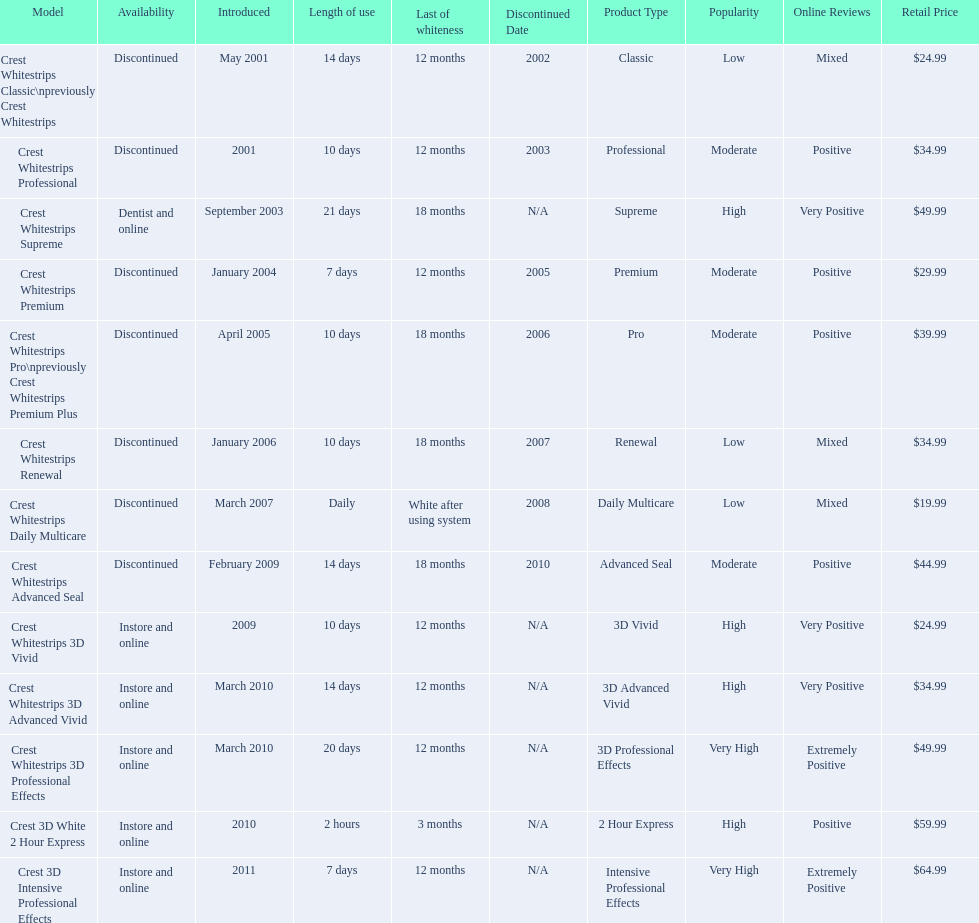What were the models of crest whitestrips? Crest Whitestrips Classic\npreviously Crest Whitestrips, Crest Whitestrips Professional, Crest Whitestrips Supreme, Crest Whitestrips Premium, Crest Whitestrips Pro\npreviously Crest Whitestrips Premium Plus, Crest Whitestrips Renewal, Crest Whitestrips Daily Multicare, Crest Whitestrips Advanced Seal, Crest Whitestrips 3D Vivid, Crest Whitestrips 3D Advanced Vivid, Crest Whitestrips 3D Professional Effects, Crest 3D White 2 Hour Express, Crest 3D Intensive Professional Effects. Can you parse all the data within this table? {'header': ['Model', 'Availability', 'Introduced', 'Length of use', 'Last of whiteness', 'Discontinued Date', 'Product Type', 'Popularity', 'Online Reviews', 'Retail Price'], 'rows': [['Crest Whitestrips Classic\\npreviously Crest Whitestrips', 'Discontinued', 'May 2001', '14 days', '12 months', '2002', 'Classic', 'Low', 'Mixed', '$24.99'], ['Crest Whitestrips Professional', 'Discontinued', '2001', '10 days', '12 months', '2003', 'Professional', 'Moderate', 'Positive', '$34.99'], ['Crest Whitestrips Supreme', 'Dentist and online', 'September 2003', '21 days', '18 months', 'N/A', 'Supreme', 'High', 'Very Positive', '$49.99'], ['Crest Whitestrips Premium', 'Discontinued', 'January 2004', '7 days', '12 months', '2005', 'Premium', 'Moderate', 'Positive', '$29.99'], ['Crest Whitestrips Pro\\npreviously Crest Whitestrips Premium Plus', 'Discontinued', 'April 2005', '10 days', '18 months', '2006', 'Pro', 'Moderate', 'Positive', '$39.99'], ['Crest Whitestrips Renewal', 'Discontinued', 'January 2006', '10 days', '18 months', '2007', 'Renewal', 'Low', 'Mixed', '$34.99'], ['Crest Whitestrips Daily Multicare', 'Discontinued', 'March 2007', 'Daily', 'White after using system', '2008', 'Daily Multicare', 'Low', 'Mixed', '$19.99'], ['Crest Whitestrips Advanced Seal', 'Discontinued', 'February 2009', '14 days', '18 months', '2010', 'Advanced Seal', 'Moderate', 'Positive', '$44.99'], ['Crest Whitestrips 3D Vivid', 'Instore and online', '2009', '10 days', '12 months', 'N/A', '3D Vivid', 'High', 'Very Positive', '$24.99'], ['Crest Whitestrips 3D Advanced Vivid', 'Instore and online', 'March 2010', '14 days', '12 months', 'N/A', '3D Advanced Vivid', 'High', 'Very Positive', '$34.99'], ['Crest Whitestrips 3D Professional Effects', 'Instore and online', 'March 2010', '20 days', '12 months', 'N/A', '3D Professional Effects', 'Very High', 'Extremely Positive', '$49.99'], ['Crest 3D White 2 Hour Express', 'Instore and online', '2010', '2 hours', '3 months', 'N/A', '2 Hour Express', 'High', 'Positive', '$59.99'], ['Crest 3D Intensive Professional Effects', 'Instore and online', '2011', '7 days', '12 months', 'N/A', 'Intensive Professional Effects', 'Very High', 'Extremely Positive', '$64.99']]} When were they introduced? May 2001, 2001, September 2003, January 2004, April 2005, January 2006, March 2007, February 2009, 2009, March 2010, March 2010, 2010, 2011. And what is their availability? Discontinued, Discontinued, Dentist and online, Discontinued, Discontinued, Discontinued, Discontinued, Discontinued, Instore and online, Instore and online, Instore and online, Instore and online, Instore and online. Along crest whitestrips 3d vivid, which discontinued model was released in 2009? Crest Whitestrips Advanced Seal. 